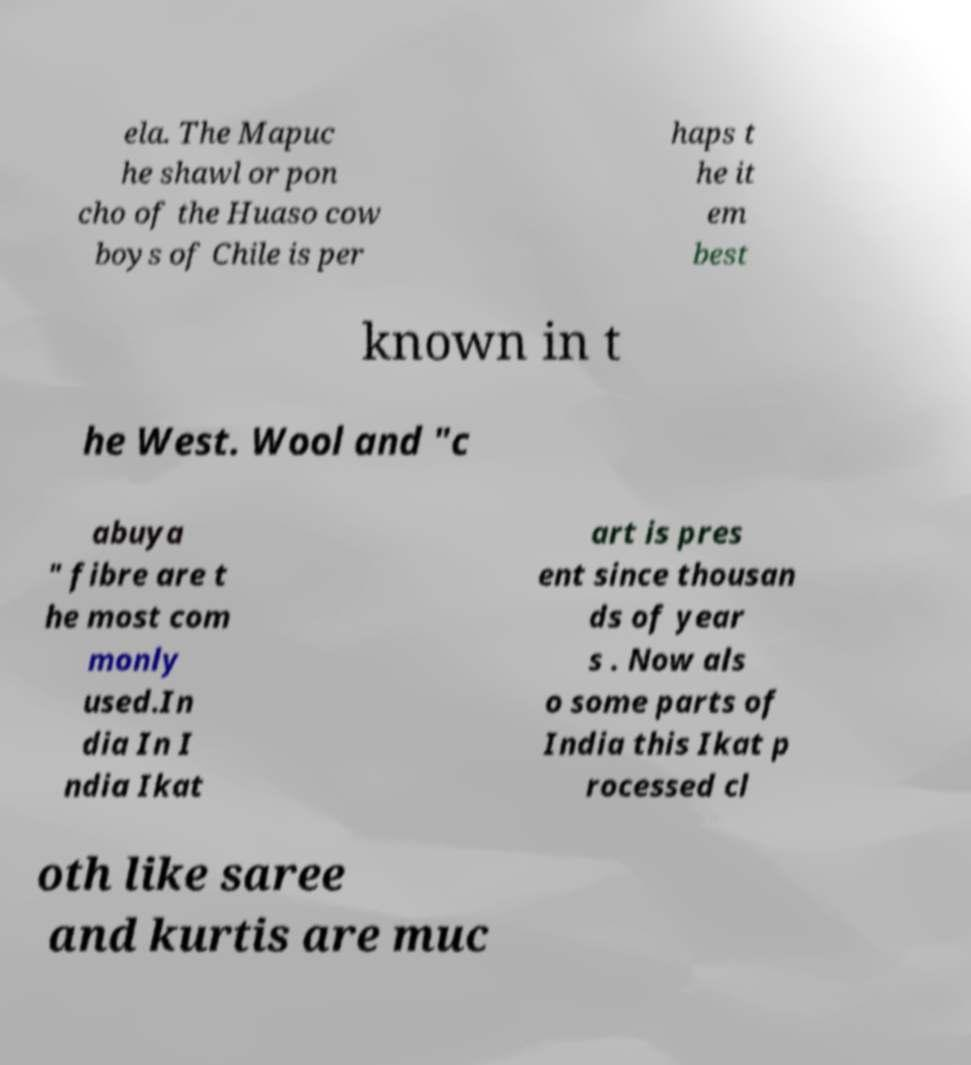What messages or text are displayed in this image? I need them in a readable, typed format. ela. The Mapuc he shawl or pon cho of the Huaso cow boys of Chile is per haps t he it em best known in t he West. Wool and "c abuya " fibre are t he most com monly used.In dia In I ndia Ikat art is pres ent since thousan ds of year s . Now als o some parts of India this Ikat p rocessed cl oth like saree and kurtis are muc 